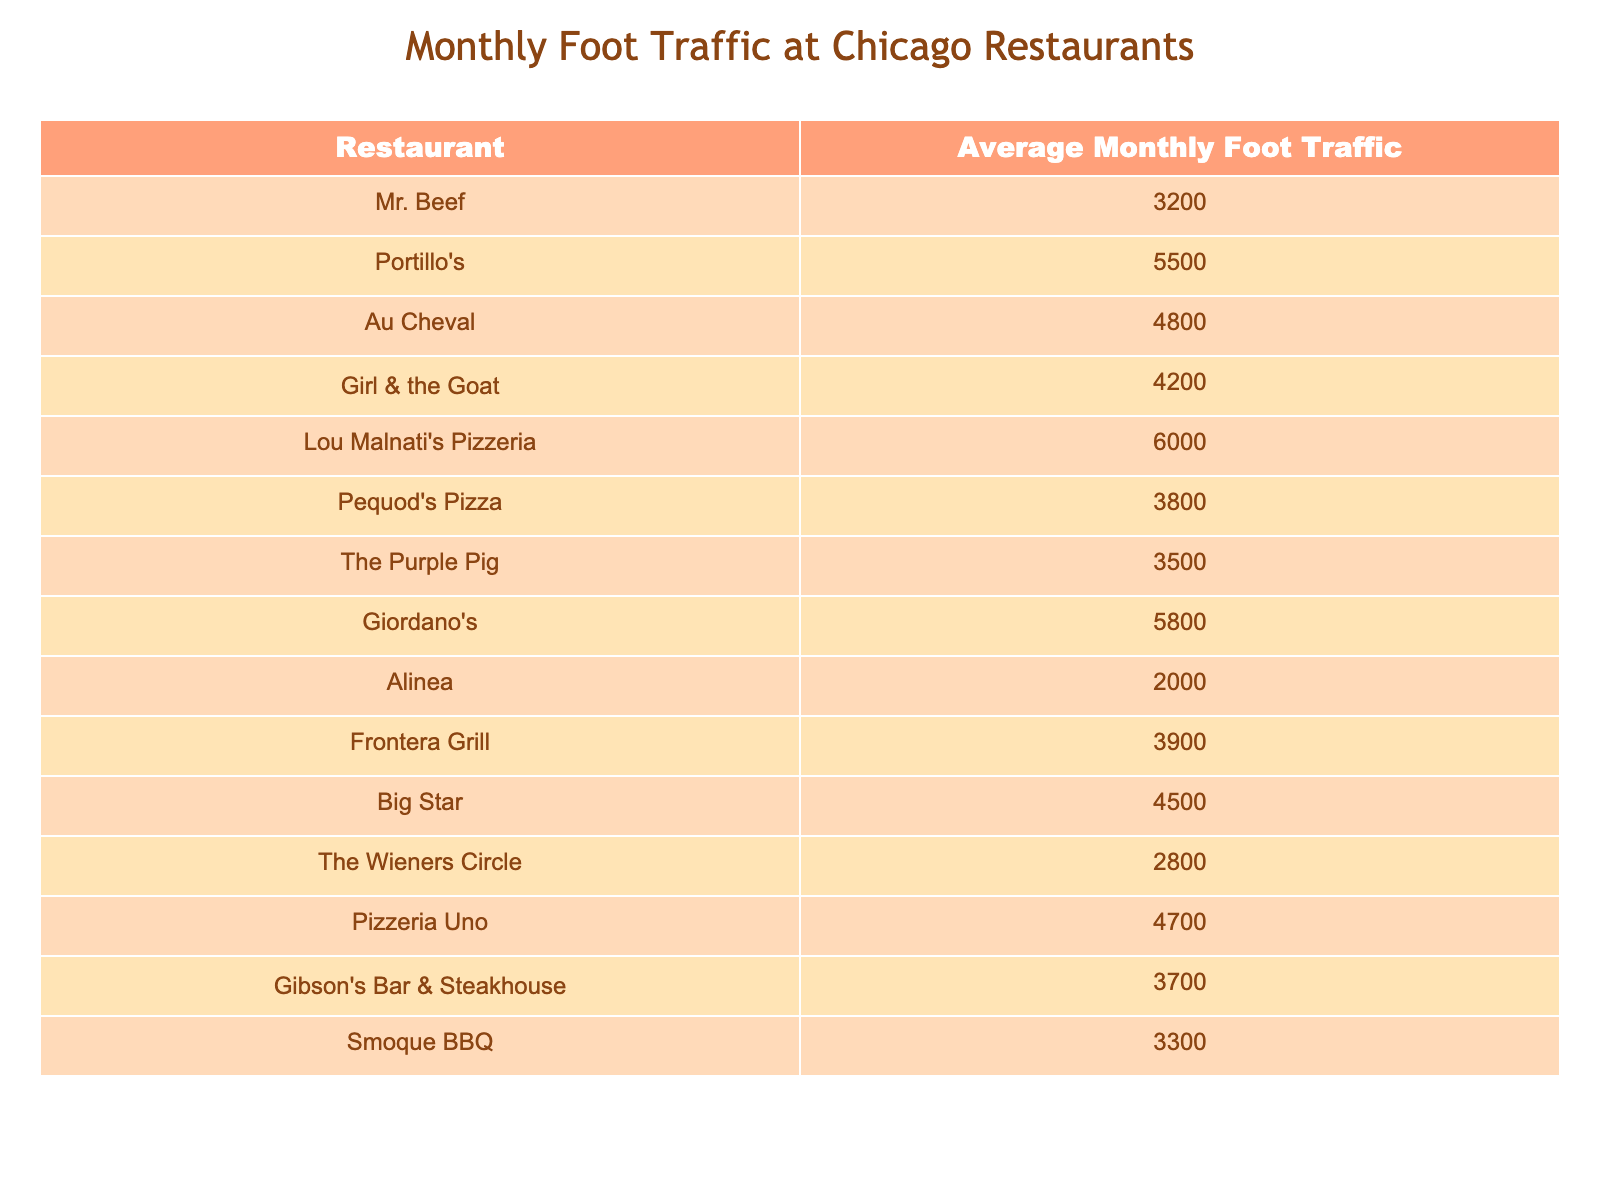What is the average monthly foot traffic of Mr. Beef? The table shows that Mr. Beef has an average monthly foot traffic of 3200.
Answer: 3200 Which restaurant has the highest average monthly foot traffic? From the table, Lou Malnati's Pizzeria has the highest foot traffic at 6000.
Answer: Lou Malnati's Pizzeria What is the average monthly foot traffic of the restaurants listed? To find the average, sum all the foot traffic values (3200 + 5500 + 4800 + 4200 + 6000 + 3800 + 3500 + 5800 + 2000 + 3900 + 4500 + 2800 + 4700 + 3700 + 3300 = 47300), then divide by 15 (the number of restaurants), which equals 3153.33.
Answer: 3153.33 How much more foot traffic does Portillo's have compared to Mr. Beef? The foot traffic for Portillo's is 5500 and for Mr. Beef it is 3200. The difference is 5500 - 3200 = 2300.
Answer: 2300 Is Mr. Beef’s foot traffic greater than that of Alinea? Mr. Beef has 3200 foot traffic while Alinea has 2000, making it true that Mr. Beef's foot traffic is greater.
Answer: Yes Which restaurant has foot traffic closest to 4000? According to the table, the closest to 4000 is The Purple Pig with 3500 and Frontera Grill with 3900.
Answer: The Purple Pig and Frontera Grill How many restaurants have foot traffic above 5000? The table lists Lou Malnati's Pizzeria (6000) and Giordano's (5800), totaling 2 restaurants above 5000.
Answer: 2 What is the difference in foot traffic between the restaurant with the highest and lowest foot traffic? The highest is at 6000 (Lou Malnati's Pizzeria) and the lowest is at 2000 (Alinea). The difference is 6000 - 2000 = 4000.
Answer: 4000 Are there any restaurants with foot traffic under 3000? The Wieners Circle has foot traffic of 2800, which is under 3000, so the answer is yes.
Answer: Yes Which restaurant has foot traffic closest to that of Pequod's Pizza? Pequod's Pizza has an average foot traffic of 3800, and the closest is Smoque BBQ with 3300.
Answer: Smoque BBQ 